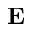<formula> <loc_0><loc_0><loc_500><loc_500>E</formula> 